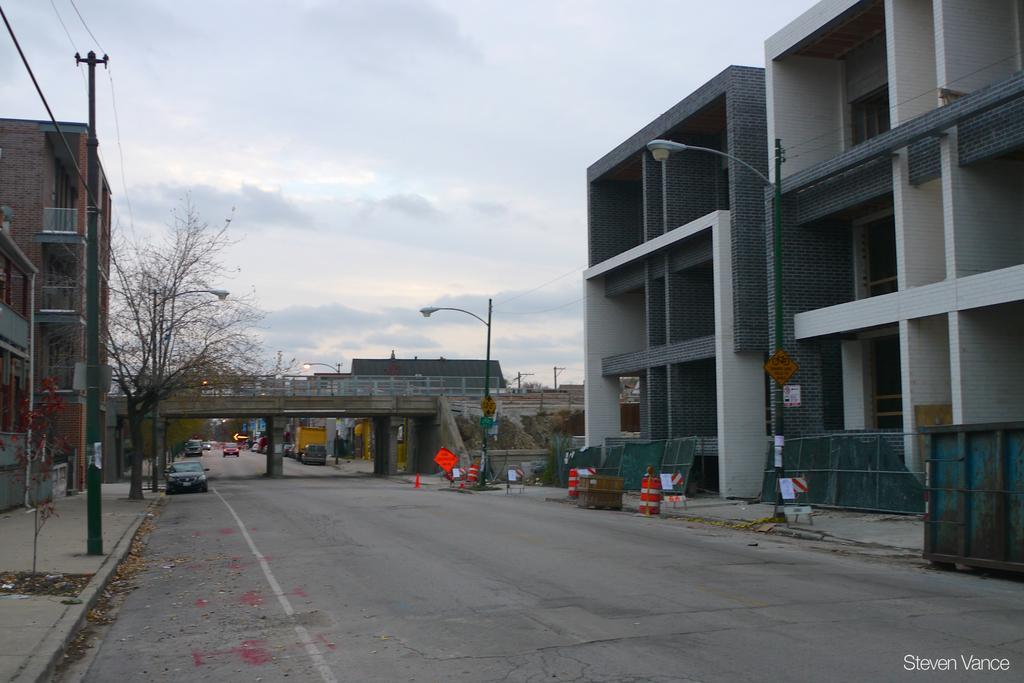Can you describe this image briefly? In the picture we can see a road on the either sides of the road we can see buildings and on the path we can see street lights to the poles and in the background, we can see a bridge with a railing to it and behind it we can see a sky with clouds. 